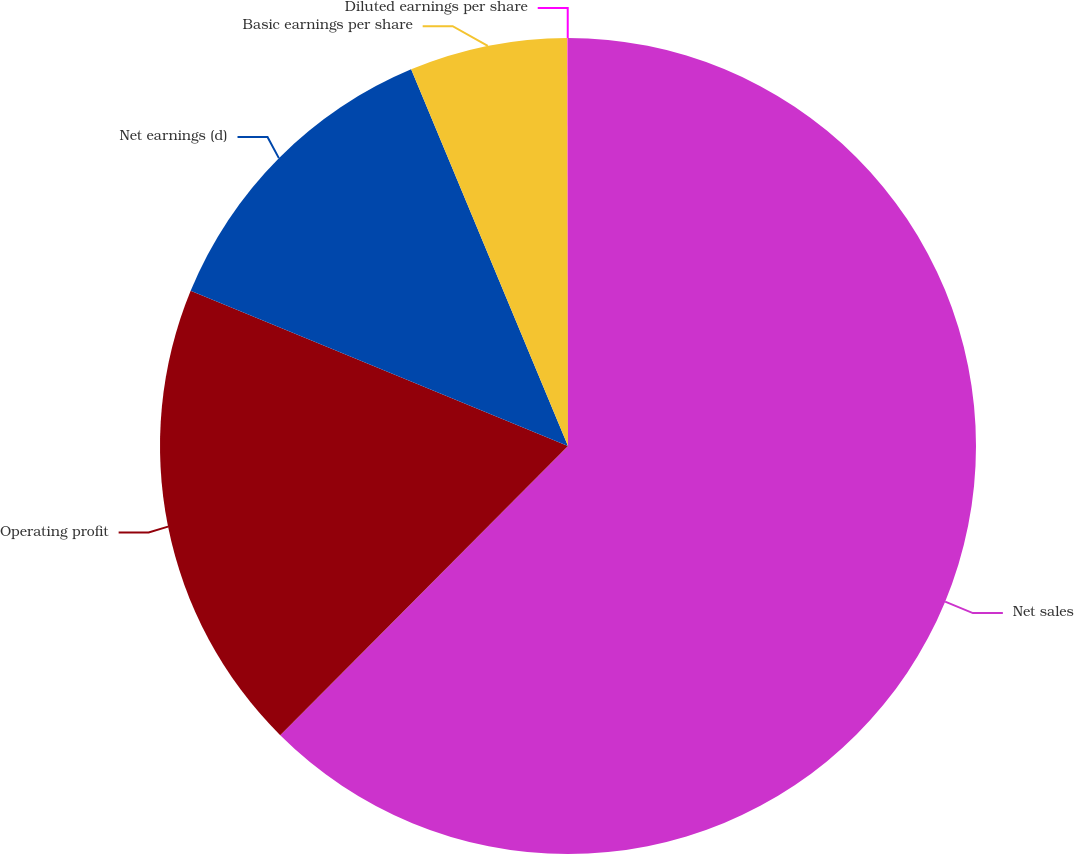Convert chart. <chart><loc_0><loc_0><loc_500><loc_500><pie_chart><fcel>Net sales<fcel>Operating profit<fcel>Net earnings (d)<fcel>Basic earnings per share<fcel>Diluted earnings per share<nl><fcel>62.46%<fcel>18.75%<fcel>12.51%<fcel>6.26%<fcel>0.02%<nl></chart> 